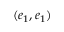Convert formula to latex. <formula><loc_0><loc_0><loc_500><loc_500>( e _ { 1 } , e _ { 1 } )</formula> 